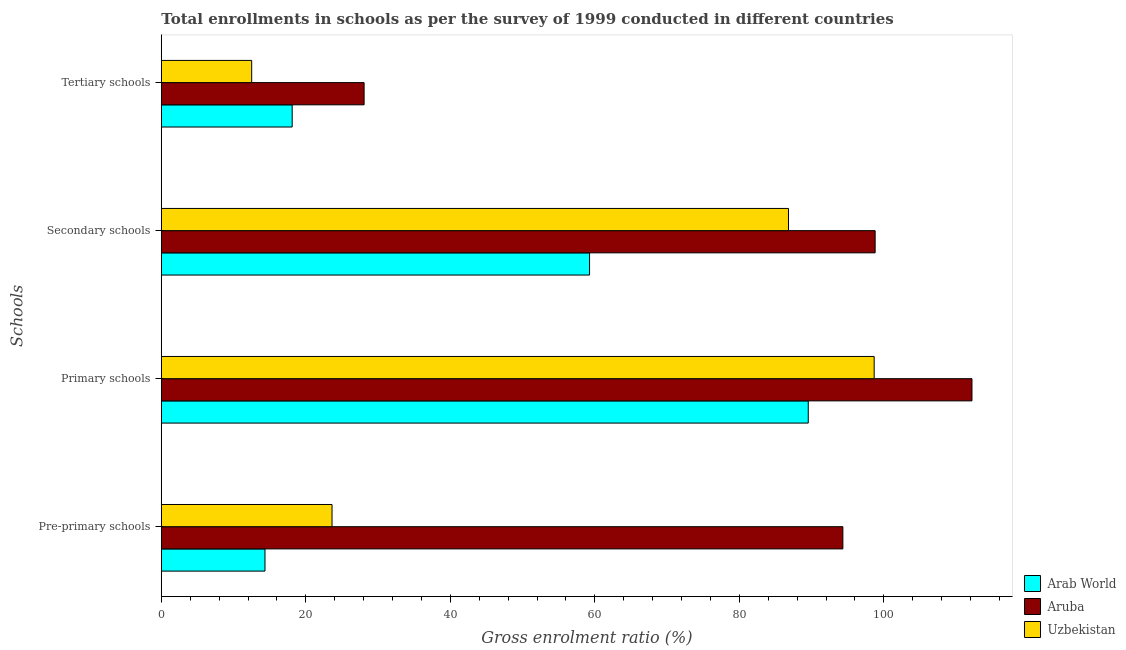How many different coloured bars are there?
Ensure brevity in your answer.  3. How many groups of bars are there?
Offer a terse response. 4. Are the number of bars per tick equal to the number of legend labels?
Ensure brevity in your answer.  Yes. How many bars are there on the 2nd tick from the top?
Your response must be concise. 3. How many bars are there on the 1st tick from the bottom?
Make the answer very short. 3. What is the label of the 4th group of bars from the top?
Offer a terse response. Pre-primary schools. What is the gross enrolment ratio in tertiary schools in Arab World?
Keep it short and to the point. 18.11. Across all countries, what is the maximum gross enrolment ratio in pre-primary schools?
Your answer should be compact. 94.33. Across all countries, what is the minimum gross enrolment ratio in tertiary schools?
Give a very brief answer. 12.51. In which country was the gross enrolment ratio in secondary schools maximum?
Offer a terse response. Aruba. In which country was the gross enrolment ratio in tertiary schools minimum?
Provide a succinct answer. Uzbekistan. What is the total gross enrolment ratio in tertiary schools in the graph?
Offer a very short reply. 58.69. What is the difference between the gross enrolment ratio in pre-primary schools in Aruba and that in Arab World?
Provide a succinct answer. 79.98. What is the difference between the gross enrolment ratio in primary schools in Uzbekistan and the gross enrolment ratio in tertiary schools in Arab World?
Your answer should be very brief. 80.55. What is the average gross enrolment ratio in secondary schools per country?
Ensure brevity in your answer.  81.62. What is the difference between the gross enrolment ratio in secondary schools and gross enrolment ratio in tertiary schools in Uzbekistan?
Give a very brief answer. 74.29. What is the ratio of the gross enrolment ratio in primary schools in Uzbekistan to that in Aruba?
Your answer should be very brief. 0.88. Is the difference between the gross enrolment ratio in tertiary schools in Uzbekistan and Arab World greater than the difference between the gross enrolment ratio in pre-primary schools in Uzbekistan and Arab World?
Provide a succinct answer. No. What is the difference between the highest and the second highest gross enrolment ratio in pre-primary schools?
Ensure brevity in your answer.  70.7. What is the difference between the highest and the lowest gross enrolment ratio in secondary schools?
Offer a terse response. 39.53. What does the 3rd bar from the top in Primary schools represents?
Ensure brevity in your answer.  Arab World. What does the 3rd bar from the bottom in Pre-primary schools represents?
Offer a terse response. Uzbekistan. Is it the case that in every country, the sum of the gross enrolment ratio in pre-primary schools and gross enrolment ratio in primary schools is greater than the gross enrolment ratio in secondary schools?
Ensure brevity in your answer.  Yes. How many countries are there in the graph?
Your answer should be compact. 3. Does the graph contain any zero values?
Keep it short and to the point. No. Does the graph contain grids?
Your answer should be very brief. No. Where does the legend appear in the graph?
Your answer should be compact. Bottom right. How many legend labels are there?
Make the answer very short. 3. How are the legend labels stacked?
Your response must be concise. Vertical. What is the title of the graph?
Keep it short and to the point. Total enrollments in schools as per the survey of 1999 conducted in different countries. Does "Dominica" appear as one of the legend labels in the graph?
Offer a terse response. No. What is the label or title of the X-axis?
Offer a terse response. Gross enrolment ratio (%). What is the label or title of the Y-axis?
Ensure brevity in your answer.  Schools. What is the Gross enrolment ratio (%) in Arab World in Pre-primary schools?
Your response must be concise. 14.35. What is the Gross enrolment ratio (%) of Aruba in Pre-primary schools?
Give a very brief answer. 94.33. What is the Gross enrolment ratio (%) in Uzbekistan in Pre-primary schools?
Keep it short and to the point. 23.63. What is the Gross enrolment ratio (%) of Arab World in Primary schools?
Your answer should be very brief. 89.54. What is the Gross enrolment ratio (%) of Aruba in Primary schools?
Your answer should be compact. 112.2. What is the Gross enrolment ratio (%) in Uzbekistan in Primary schools?
Ensure brevity in your answer.  98.66. What is the Gross enrolment ratio (%) of Arab World in Secondary schools?
Keep it short and to the point. 59.27. What is the Gross enrolment ratio (%) in Aruba in Secondary schools?
Ensure brevity in your answer.  98.8. What is the Gross enrolment ratio (%) of Uzbekistan in Secondary schools?
Give a very brief answer. 86.8. What is the Gross enrolment ratio (%) of Arab World in Tertiary schools?
Give a very brief answer. 18.11. What is the Gross enrolment ratio (%) in Aruba in Tertiary schools?
Keep it short and to the point. 28.07. What is the Gross enrolment ratio (%) in Uzbekistan in Tertiary schools?
Offer a terse response. 12.51. Across all Schools, what is the maximum Gross enrolment ratio (%) of Arab World?
Ensure brevity in your answer.  89.54. Across all Schools, what is the maximum Gross enrolment ratio (%) in Aruba?
Offer a terse response. 112.2. Across all Schools, what is the maximum Gross enrolment ratio (%) in Uzbekistan?
Your response must be concise. 98.66. Across all Schools, what is the minimum Gross enrolment ratio (%) in Arab World?
Ensure brevity in your answer.  14.35. Across all Schools, what is the minimum Gross enrolment ratio (%) of Aruba?
Make the answer very short. 28.07. Across all Schools, what is the minimum Gross enrolment ratio (%) in Uzbekistan?
Provide a short and direct response. 12.51. What is the total Gross enrolment ratio (%) in Arab World in the graph?
Give a very brief answer. 181.27. What is the total Gross enrolment ratio (%) in Aruba in the graph?
Offer a very short reply. 333.39. What is the total Gross enrolment ratio (%) of Uzbekistan in the graph?
Offer a terse response. 221.6. What is the difference between the Gross enrolment ratio (%) in Arab World in Pre-primary schools and that in Primary schools?
Give a very brief answer. -75.19. What is the difference between the Gross enrolment ratio (%) of Aruba in Pre-primary schools and that in Primary schools?
Provide a short and direct response. -17.87. What is the difference between the Gross enrolment ratio (%) in Uzbekistan in Pre-primary schools and that in Primary schools?
Your answer should be very brief. -75.03. What is the difference between the Gross enrolment ratio (%) of Arab World in Pre-primary schools and that in Secondary schools?
Ensure brevity in your answer.  -44.92. What is the difference between the Gross enrolment ratio (%) of Aruba in Pre-primary schools and that in Secondary schools?
Keep it short and to the point. -4.47. What is the difference between the Gross enrolment ratio (%) of Uzbekistan in Pre-primary schools and that in Secondary schools?
Offer a terse response. -63.17. What is the difference between the Gross enrolment ratio (%) of Arab World in Pre-primary schools and that in Tertiary schools?
Provide a short and direct response. -3.76. What is the difference between the Gross enrolment ratio (%) of Aruba in Pre-primary schools and that in Tertiary schools?
Ensure brevity in your answer.  66.26. What is the difference between the Gross enrolment ratio (%) in Uzbekistan in Pre-primary schools and that in Tertiary schools?
Your response must be concise. 11.12. What is the difference between the Gross enrolment ratio (%) of Arab World in Primary schools and that in Secondary schools?
Your answer should be compact. 30.27. What is the difference between the Gross enrolment ratio (%) of Aruba in Primary schools and that in Secondary schools?
Provide a short and direct response. 13.4. What is the difference between the Gross enrolment ratio (%) of Uzbekistan in Primary schools and that in Secondary schools?
Your answer should be compact. 11.86. What is the difference between the Gross enrolment ratio (%) in Arab World in Primary schools and that in Tertiary schools?
Your answer should be compact. 71.42. What is the difference between the Gross enrolment ratio (%) of Aruba in Primary schools and that in Tertiary schools?
Give a very brief answer. 84.13. What is the difference between the Gross enrolment ratio (%) of Uzbekistan in Primary schools and that in Tertiary schools?
Make the answer very short. 86.16. What is the difference between the Gross enrolment ratio (%) of Arab World in Secondary schools and that in Tertiary schools?
Keep it short and to the point. 41.16. What is the difference between the Gross enrolment ratio (%) in Aruba in Secondary schools and that in Tertiary schools?
Your response must be concise. 70.73. What is the difference between the Gross enrolment ratio (%) in Uzbekistan in Secondary schools and that in Tertiary schools?
Make the answer very short. 74.29. What is the difference between the Gross enrolment ratio (%) of Arab World in Pre-primary schools and the Gross enrolment ratio (%) of Aruba in Primary schools?
Provide a short and direct response. -97.85. What is the difference between the Gross enrolment ratio (%) of Arab World in Pre-primary schools and the Gross enrolment ratio (%) of Uzbekistan in Primary schools?
Offer a terse response. -84.31. What is the difference between the Gross enrolment ratio (%) of Aruba in Pre-primary schools and the Gross enrolment ratio (%) of Uzbekistan in Primary schools?
Offer a very short reply. -4.33. What is the difference between the Gross enrolment ratio (%) in Arab World in Pre-primary schools and the Gross enrolment ratio (%) in Aruba in Secondary schools?
Offer a terse response. -84.45. What is the difference between the Gross enrolment ratio (%) in Arab World in Pre-primary schools and the Gross enrolment ratio (%) in Uzbekistan in Secondary schools?
Your answer should be very brief. -72.45. What is the difference between the Gross enrolment ratio (%) in Aruba in Pre-primary schools and the Gross enrolment ratio (%) in Uzbekistan in Secondary schools?
Provide a short and direct response. 7.53. What is the difference between the Gross enrolment ratio (%) in Arab World in Pre-primary schools and the Gross enrolment ratio (%) in Aruba in Tertiary schools?
Your response must be concise. -13.72. What is the difference between the Gross enrolment ratio (%) of Arab World in Pre-primary schools and the Gross enrolment ratio (%) of Uzbekistan in Tertiary schools?
Offer a terse response. 1.84. What is the difference between the Gross enrolment ratio (%) in Aruba in Pre-primary schools and the Gross enrolment ratio (%) in Uzbekistan in Tertiary schools?
Provide a short and direct response. 81.82. What is the difference between the Gross enrolment ratio (%) of Arab World in Primary schools and the Gross enrolment ratio (%) of Aruba in Secondary schools?
Your answer should be compact. -9.26. What is the difference between the Gross enrolment ratio (%) of Arab World in Primary schools and the Gross enrolment ratio (%) of Uzbekistan in Secondary schools?
Ensure brevity in your answer.  2.74. What is the difference between the Gross enrolment ratio (%) of Aruba in Primary schools and the Gross enrolment ratio (%) of Uzbekistan in Secondary schools?
Ensure brevity in your answer.  25.4. What is the difference between the Gross enrolment ratio (%) of Arab World in Primary schools and the Gross enrolment ratio (%) of Aruba in Tertiary schools?
Give a very brief answer. 61.47. What is the difference between the Gross enrolment ratio (%) of Arab World in Primary schools and the Gross enrolment ratio (%) of Uzbekistan in Tertiary schools?
Keep it short and to the point. 77.03. What is the difference between the Gross enrolment ratio (%) of Aruba in Primary schools and the Gross enrolment ratio (%) of Uzbekistan in Tertiary schools?
Offer a terse response. 99.69. What is the difference between the Gross enrolment ratio (%) of Arab World in Secondary schools and the Gross enrolment ratio (%) of Aruba in Tertiary schools?
Ensure brevity in your answer.  31.2. What is the difference between the Gross enrolment ratio (%) of Arab World in Secondary schools and the Gross enrolment ratio (%) of Uzbekistan in Tertiary schools?
Provide a short and direct response. 46.76. What is the difference between the Gross enrolment ratio (%) in Aruba in Secondary schools and the Gross enrolment ratio (%) in Uzbekistan in Tertiary schools?
Give a very brief answer. 86.29. What is the average Gross enrolment ratio (%) in Arab World per Schools?
Make the answer very short. 45.32. What is the average Gross enrolment ratio (%) of Aruba per Schools?
Offer a very short reply. 83.35. What is the average Gross enrolment ratio (%) of Uzbekistan per Schools?
Your answer should be very brief. 55.4. What is the difference between the Gross enrolment ratio (%) in Arab World and Gross enrolment ratio (%) in Aruba in Pre-primary schools?
Keep it short and to the point. -79.98. What is the difference between the Gross enrolment ratio (%) in Arab World and Gross enrolment ratio (%) in Uzbekistan in Pre-primary schools?
Provide a succinct answer. -9.28. What is the difference between the Gross enrolment ratio (%) of Aruba and Gross enrolment ratio (%) of Uzbekistan in Pre-primary schools?
Your response must be concise. 70.7. What is the difference between the Gross enrolment ratio (%) of Arab World and Gross enrolment ratio (%) of Aruba in Primary schools?
Keep it short and to the point. -22.66. What is the difference between the Gross enrolment ratio (%) of Arab World and Gross enrolment ratio (%) of Uzbekistan in Primary schools?
Keep it short and to the point. -9.12. What is the difference between the Gross enrolment ratio (%) of Aruba and Gross enrolment ratio (%) of Uzbekistan in Primary schools?
Provide a succinct answer. 13.54. What is the difference between the Gross enrolment ratio (%) of Arab World and Gross enrolment ratio (%) of Aruba in Secondary schools?
Provide a succinct answer. -39.53. What is the difference between the Gross enrolment ratio (%) of Arab World and Gross enrolment ratio (%) of Uzbekistan in Secondary schools?
Offer a very short reply. -27.53. What is the difference between the Gross enrolment ratio (%) in Aruba and Gross enrolment ratio (%) in Uzbekistan in Secondary schools?
Keep it short and to the point. 11.99. What is the difference between the Gross enrolment ratio (%) in Arab World and Gross enrolment ratio (%) in Aruba in Tertiary schools?
Offer a terse response. -9.95. What is the difference between the Gross enrolment ratio (%) in Arab World and Gross enrolment ratio (%) in Uzbekistan in Tertiary schools?
Make the answer very short. 5.61. What is the difference between the Gross enrolment ratio (%) in Aruba and Gross enrolment ratio (%) in Uzbekistan in Tertiary schools?
Your response must be concise. 15.56. What is the ratio of the Gross enrolment ratio (%) of Arab World in Pre-primary schools to that in Primary schools?
Ensure brevity in your answer.  0.16. What is the ratio of the Gross enrolment ratio (%) in Aruba in Pre-primary schools to that in Primary schools?
Your answer should be compact. 0.84. What is the ratio of the Gross enrolment ratio (%) of Uzbekistan in Pre-primary schools to that in Primary schools?
Your response must be concise. 0.24. What is the ratio of the Gross enrolment ratio (%) of Arab World in Pre-primary schools to that in Secondary schools?
Provide a succinct answer. 0.24. What is the ratio of the Gross enrolment ratio (%) in Aruba in Pre-primary schools to that in Secondary schools?
Your answer should be compact. 0.95. What is the ratio of the Gross enrolment ratio (%) of Uzbekistan in Pre-primary schools to that in Secondary schools?
Your response must be concise. 0.27. What is the ratio of the Gross enrolment ratio (%) in Arab World in Pre-primary schools to that in Tertiary schools?
Make the answer very short. 0.79. What is the ratio of the Gross enrolment ratio (%) of Aruba in Pre-primary schools to that in Tertiary schools?
Your answer should be compact. 3.36. What is the ratio of the Gross enrolment ratio (%) of Uzbekistan in Pre-primary schools to that in Tertiary schools?
Your answer should be compact. 1.89. What is the ratio of the Gross enrolment ratio (%) of Arab World in Primary schools to that in Secondary schools?
Provide a short and direct response. 1.51. What is the ratio of the Gross enrolment ratio (%) of Aruba in Primary schools to that in Secondary schools?
Your answer should be compact. 1.14. What is the ratio of the Gross enrolment ratio (%) of Uzbekistan in Primary schools to that in Secondary schools?
Give a very brief answer. 1.14. What is the ratio of the Gross enrolment ratio (%) of Arab World in Primary schools to that in Tertiary schools?
Give a very brief answer. 4.94. What is the ratio of the Gross enrolment ratio (%) in Aruba in Primary schools to that in Tertiary schools?
Keep it short and to the point. 4. What is the ratio of the Gross enrolment ratio (%) in Uzbekistan in Primary schools to that in Tertiary schools?
Your response must be concise. 7.89. What is the ratio of the Gross enrolment ratio (%) in Arab World in Secondary schools to that in Tertiary schools?
Provide a short and direct response. 3.27. What is the ratio of the Gross enrolment ratio (%) of Aruba in Secondary schools to that in Tertiary schools?
Your answer should be very brief. 3.52. What is the ratio of the Gross enrolment ratio (%) in Uzbekistan in Secondary schools to that in Tertiary schools?
Ensure brevity in your answer.  6.94. What is the difference between the highest and the second highest Gross enrolment ratio (%) in Arab World?
Ensure brevity in your answer.  30.27. What is the difference between the highest and the second highest Gross enrolment ratio (%) of Aruba?
Offer a very short reply. 13.4. What is the difference between the highest and the second highest Gross enrolment ratio (%) of Uzbekistan?
Make the answer very short. 11.86. What is the difference between the highest and the lowest Gross enrolment ratio (%) in Arab World?
Keep it short and to the point. 75.19. What is the difference between the highest and the lowest Gross enrolment ratio (%) in Aruba?
Make the answer very short. 84.13. What is the difference between the highest and the lowest Gross enrolment ratio (%) of Uzbekistan?
Keep it short and to the point. 86.16. 